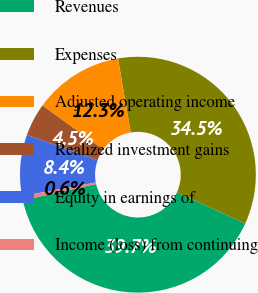Convert chart. <chart><loc_0><loc_0><loc_500><loc_500><pie_chart><fcel>Revenues<fcel>Expenses<fcel>Adjusted operating income<fcel>Realized investment gains<fcel>Equity in earnings of<fcel>Income (loss) from continuing<nl><fcel>39.73%<fcel>34.49%<fcel>12.32%<fcel>4.49%<fcel>8.4%<fcel>0.57%<nl></chart> 